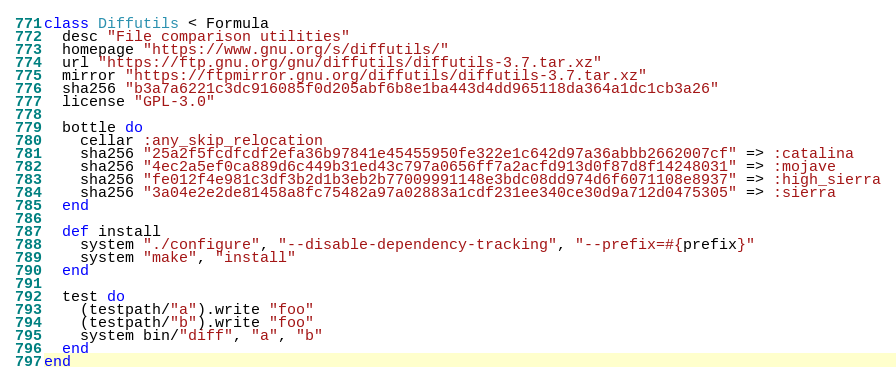<code> <loc_0><loc_0><loc_500><loc_500><_Ruby_>class Diffutils < Formula
  desc "File comparison utilities"
  homepage "https://www.gnu.org/s/diffutils/"
  url "https://ftp.gnu.org/gnu/diffutils/diffutils-3.7.tar.xz"
  mirror "https://ftpmirror.gnu.org/diffutils/diffutils-3.7.tar.xz"
  sha256 "b3a7a6221c3dc916085f0d205abf6b8e1ba443d4dd965118da364a1dc1cb3a26"
  license "GPL-3.0"

  bottle do
    cellar :any_skip_relocation
    sha256 "25a2f5fcdfcdf2efa36b97841e45455950fe322e1c642d97a36abbb2662007cf" => :catalina
    sha256 "4ec2a5ef0ca889d6c449b31ed43c797a0656ff7a2acfd913d0f87d8f14248031" => :mojave
    sha256 "fe012f4e981c3df3b2d1b3eb2b77009991148e3bdc08dd974d6f6071108e8937" => :high_sierra
    sha256 "3a04e2e2de81458a8fc75482a97a02883a1cdf231ee340ce30d9a712d0475305" => :sierra
  end

  def install
    system "./configure", "--disable-dependency-tracking", "--prefix=#{prefix}"
    system "make", "install"
  end

  test do
    (testpath/"a").write "foo"
    (testpath/"b").write "foo"
    system bin/"diff", "a", "b"
  end
end
</code> 